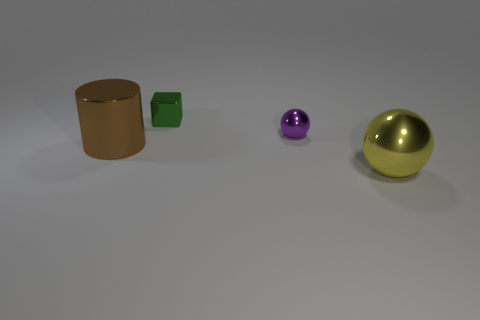Add 1 tiny yellow matte balls. How many objects exist? 5 Subtract all blocks. How many objects are left? 3 Add 3 big blue cubes. How many big blue cubes exist? 3 Subtract 0 blue cylinders. How many objects are left? 4 Subtract all large brown metallic cylinders. Subtract all brown cylinders. How many objects are left? 2 Add 1 brown metallic things. How many brown metallic things are left? 2 